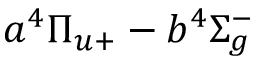Convert formula to latex. <formula><loc_0><loc_0><loc_500><loc_500>a ^ { 4 } \Pi _ { u + } - b ^ { 4 } \Sigma _ { g } ^ { - }</formula> 